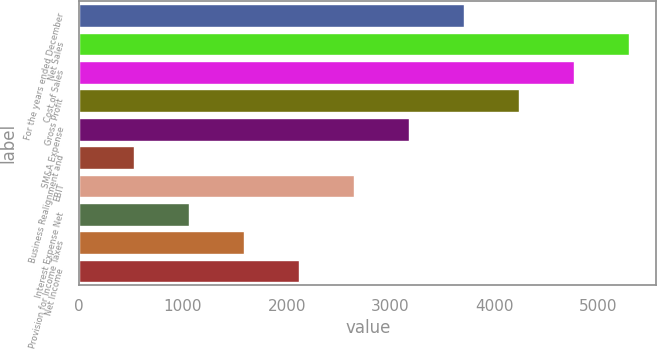Convert chart. <chart><loc_0><loc_0><loc_500><loc_500><bar_chart><fcel>For the years ended December<fcel>Net Sales<fcel>Cost of Sales<fcel>Gross Profit<fcel>SM&A Expense<fcel>Business Realignment and<fcel>EBIT<fcel>Interest Expense Net<fcel>Provision for Income Taxes<fcel>Net Income<nl><fcel>3709.66<fcel>5298.7<fcel>4769.02<fcel>4239.34<fcel>3179.98<fcel>531.58<fcel>2650.3<fcel>1061.26<fcel>1590.94<fcel>2120.62<nl></chart> 